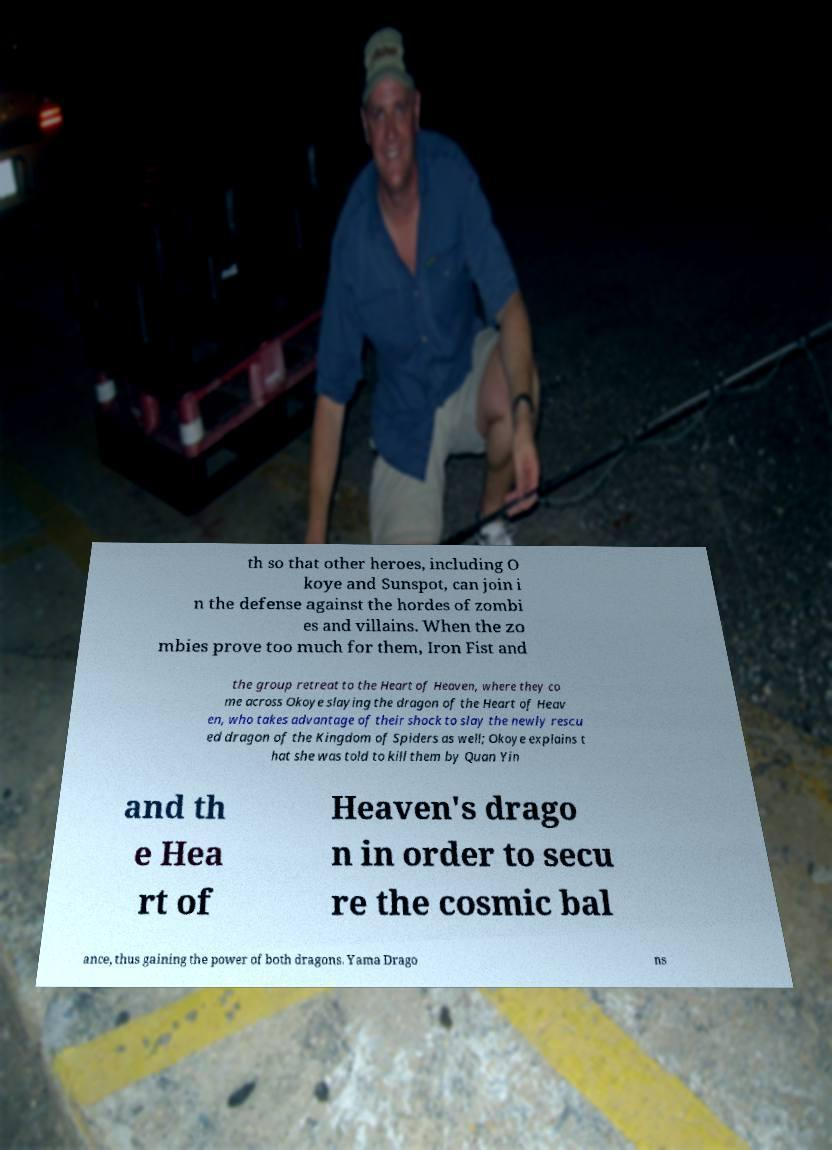Could you extract and type out the text from this image? th so that other heroes, including O koye and Sunspot, can join i n the defense against the hordes of zombi es and villains. When the zo mbies prove too much for them, Iron Fist and the group retreat to the Heart of Heaven, where they co me across Okoye slaying the dragon of the Heart of Heav en, who takes advantage of their shock to slay the newly rescu ed dragon of the Kingdom of Spiders as well; Okoye explains t hat she was told to kill them by Quan Yin and th e Hea rt of Heaven's drago n in order to secu re the cosmic bal ance, thus gaining the power of both dragons. Yama Drago ns 